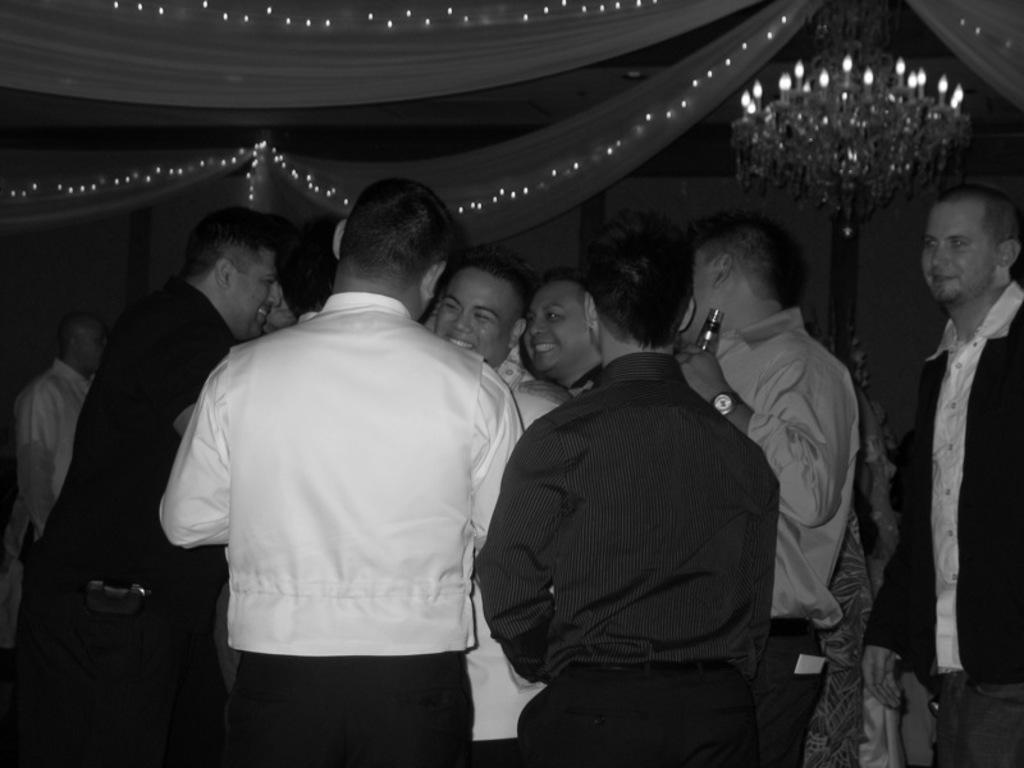How many people are in the image? There is a group of people in the image. What are the people doing in the image? The people are standing. What are the people wearing in the image? The people are wearing clothes. What can be seen at the top of the image? There are decorations at the top of the image, and a chandelier is in the top right of the image. What type of train can be seen passing by in the image? There is no train present in the image. What kind of bait is being used by the beggar in the image? There is no beggar or bait present in the image. 